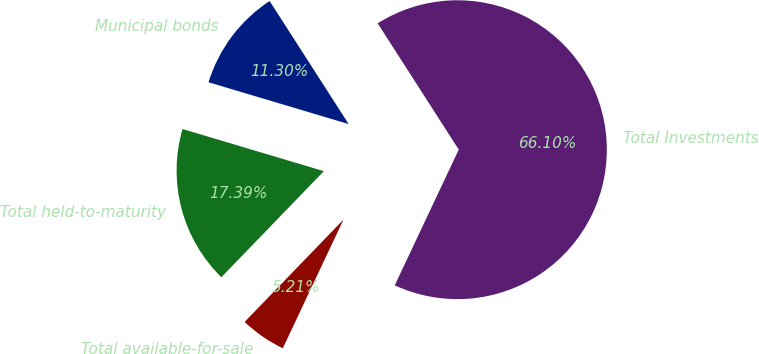Convert chart to OTSL. <chart><loc_0><loc_0><loc_500><loc_500><pie_chart><fcel>Municipal bonds<fcel>Total held-to-maturity<fcel>Total available-for-sale<fcel>Total Investments<nl><fcel>11.3%<fcel>17.39%<fcel>5.21%<fcel>66.1%<nl></chart> 